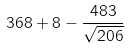Convert formula to latex. <formula><loc_0><loc_0><loc_500><loc_500>3 6 8 + 8 - \frac { 4 8 3 } { \sqrt { 2 0 6 } }</formula> 